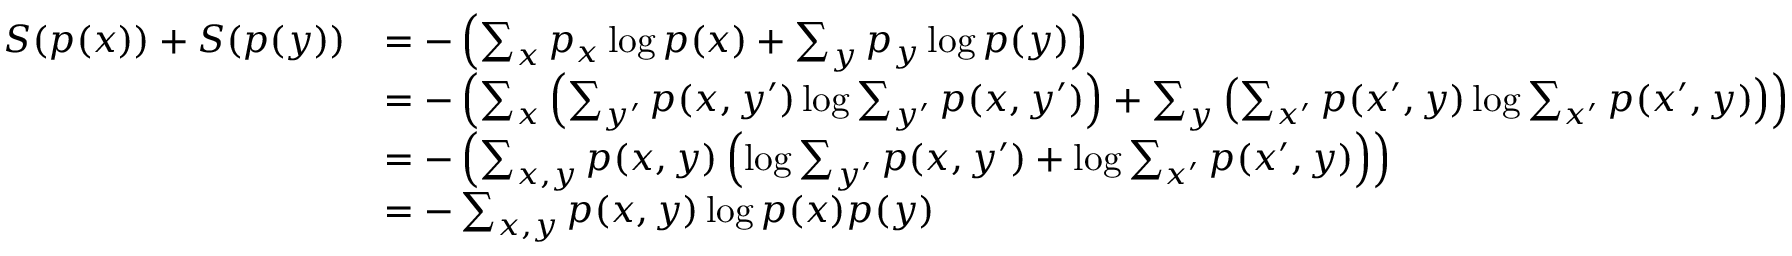<formula> <loc_0><loc_0><loc_500><loc_500>{ \begin{array} { r l } { S ( p ( x ) ) + S ( p ( y ) ) } & { = - \left ( \sum _ { x } p _ { x } \log p ( x ) + \sum _ { y } p _ { y } \log p ( y ) \right ) } \\ & { = - \left ( \sum _ { x } \left ( \sum _ { y ^ { \prime } } p ( x , y ^ { \prime } ) \log \sum _ { y ^ { \prime } } p ( x , y ^ { \prime } ) \right ) + \sum _ { y } \left ( \sum _ { x ^ { \prime } } p ( x ^ { \prime } , y ) \log \sum _ { x ^ { \prime } } p ( x ^ { \prime } , y ) \right ) \right ) } \\ & { = - \left ( \sum _ { x , y } p ( x , y ) \left ( \log \sum _ { y ^ { \prime } } p ( x , y ^ { \prime } ) + \log \sum _ { x ^ { \prime } } p ( x ^ { \prime } , y ) \right ) \right ) } \\ & { = - \sum _ { x , y } p ( x , y ) \log p ( x ) p ( y ) } \end{array} }</formula> 